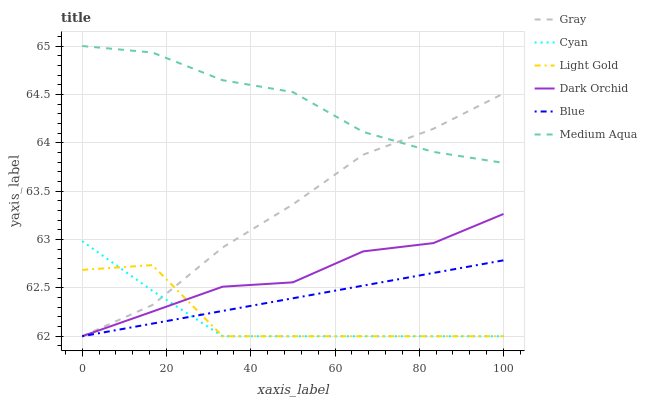Does Cyan have the minimum area under the curve?
Answer yes or no. Yes. Does Medium Aqua have the maximum area under the curve?
Answer yes or no. Yes. Does Gray have the minimum area under the curve?
Answer yes or no. No. Does Gray have the maximum area under the curve?
Answer yes or no. No. Is Blue the smoothest?
Answer yes or no. Yes. Is Light Gold the roughest?
Answer yes or no. Yes. Is Gray the smoothest?
Answer yes or no. No. Is Gray the roughest?
Answer yes or no. No. Does Blue have the lowest value?
Answer yes or no. Yes. Does Medium Aqua have the lowest value?
Answer yes or no. No. Does Medium Aqua have the highest value?
Answer yes or no. Yes. Does Gray have the highest value?
Answer yes or no. No. Is Light Gold less than Medium Aqua?
Answer yes or no. Yes. Is Medium Aqua greater than Light Gold?
Answer yes or no. Yes. Does Dark Orchid intersect Gray?
Answer yes or no. Yes. Is Dark Orchid less than Gray?
Answer yes or no. No. Is Dark Orchid greater than Gray?
Answer yes or no. No. Does Light Gold intersect Medium Aqua?
Answer yes or no. No. 